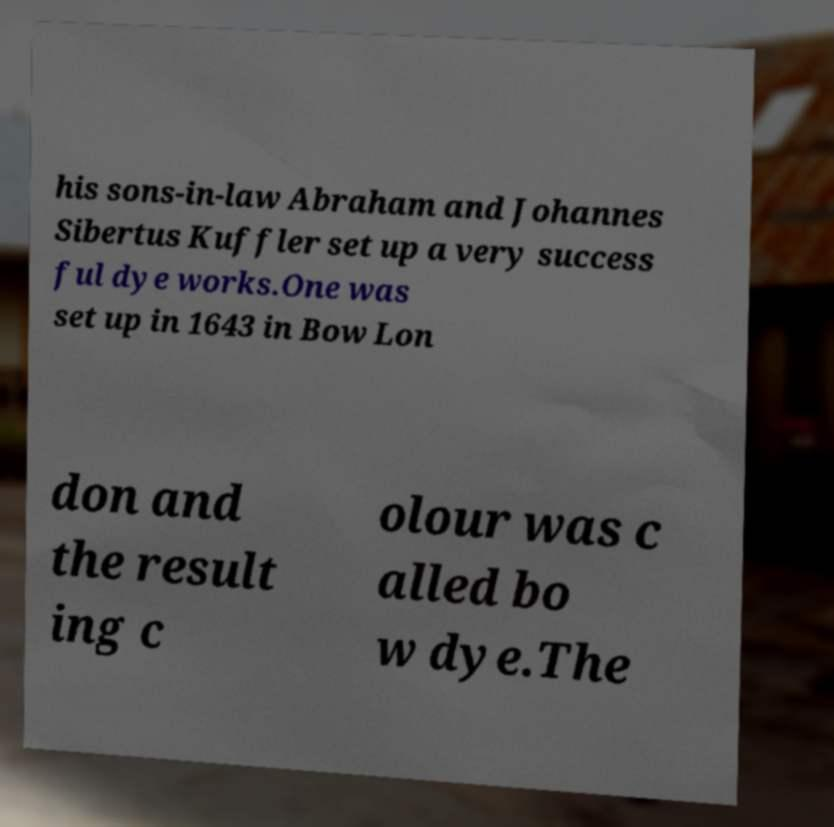Could you assist in decoding the text presented in this image and type it out clearly? his sons-in-law Abraham and Johannes Sibertus Kuffler set up a very success ful dye works.One was set up in 1643 in Bow Lon don and the result ing c olour was c alled bo w dye.The 